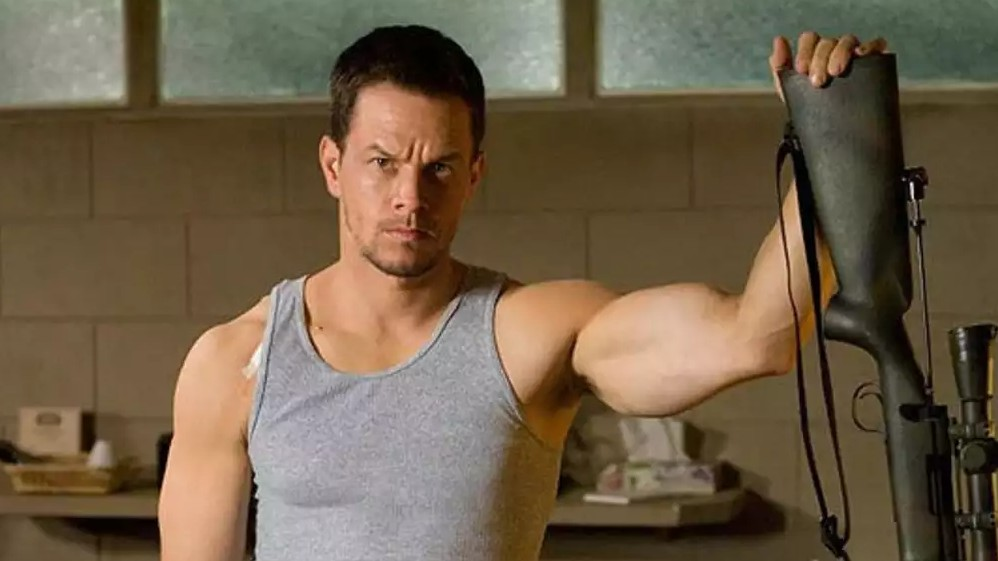Imagine a fantasy scenario where this character is a mythical warrior. Describe it in detail. In a realm where magic and myth intertwine, this character is a renowned warrior, protector of the enchanted forest. Donning ancient armor imbued with mystical runes, he wields a sacred weapon, not just any rifle but a mystical staff transformed by sorcery to harness the forces of nature. The room he stands in is his sanctuary, adorned with relics and artifacts of battles fought and won. His keen eyes now focus on an approaching doom – a dark sorcerer threatening to unleash chaos upon the land. Our warrior's mind races through ancient spells, preparing for a clash that will determine the fate of the realm. With a heart steeled by past victories and losses, he steps towards the twilight, ready to defend the harmony of his world. 